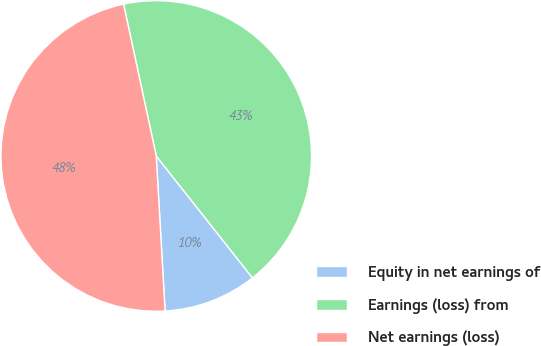<chart> <loc_0><loc_0><loc_500><loc_500><pie_chart><fcel>Equity in net earnings of<fcel>Earnings (loss) from<fcel>Net earnings (loss)<nl><fcel>9.73%<fcel>42.74%<fcel>47.54%<nl></chart> 